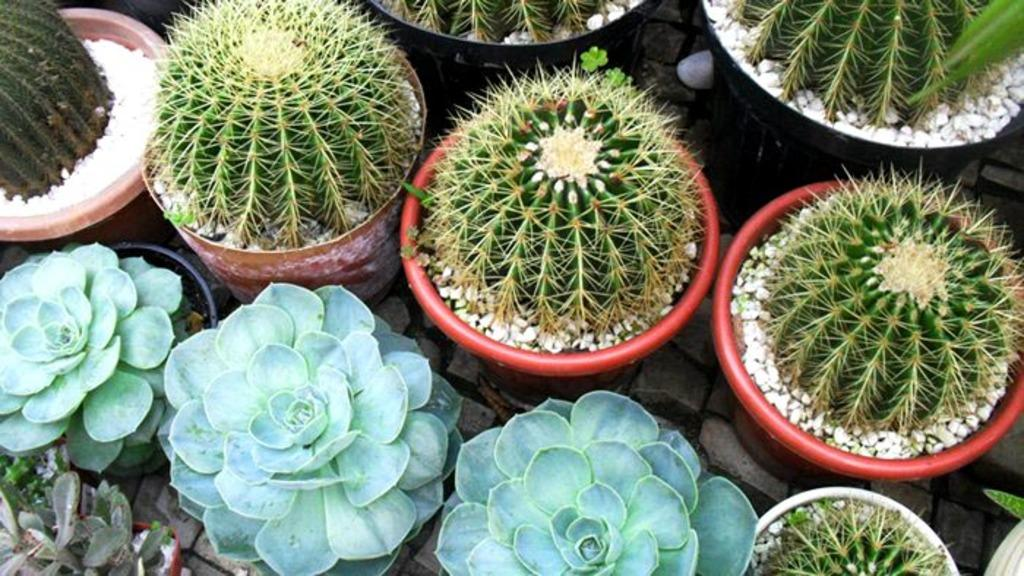What type of plants are visible in the image? There are potted plants in the foreground of the image. Where is the cemetery located in the image? There is no cemetery present in the image; it only features potted plants in the foreground. What type of achievement is the achiever celebrating in the image? There is no achiever or achievement depicted in the image; it only features potted plants in the foreground. 